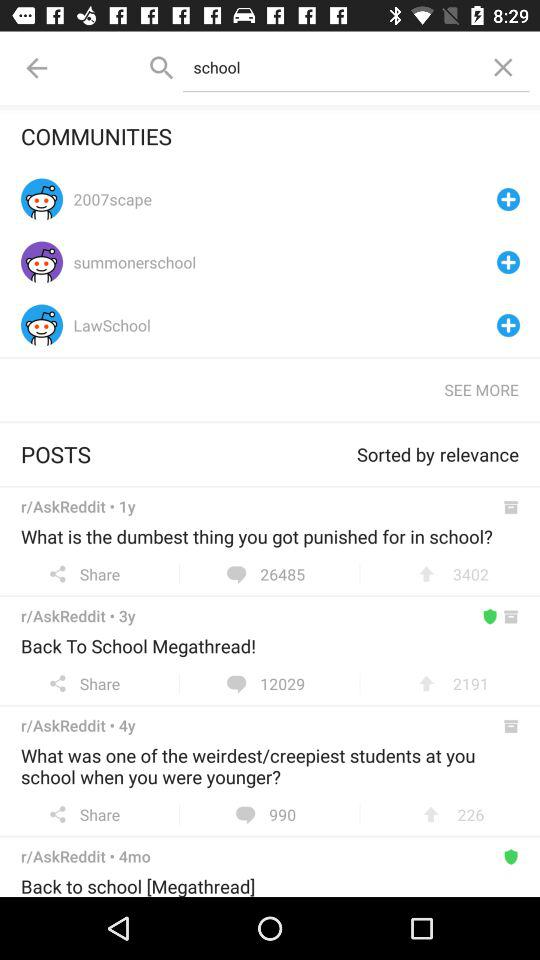Which post has the highest comment count?
When the provided information is insufficient, respond with <no answer>. <no answer> 